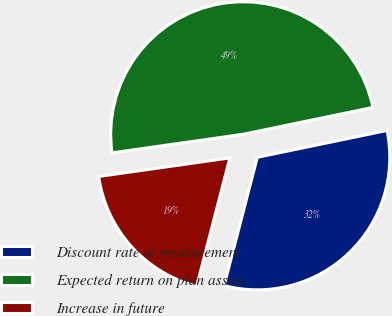Convert chart to OTSL. <chart><loc_0><loc_0><loc_500><loc_500><pie_chart><fcel>Discount rate at measurement<fcel>Expected return on plan assets<fcel>Increase in future<nl><fcel>32.28%<fcel>48.99%<fcel>18.73%<nl></chart> 